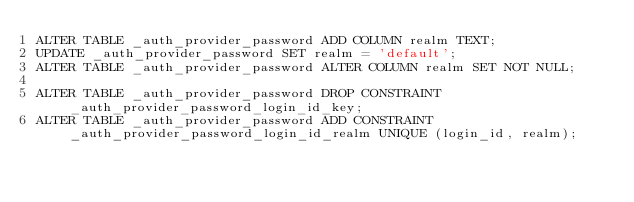Convert code to text. <code><loc_0><loc_0><loc_500><loc_500><_SQL_>ALTER TABLE _auth_provider_password ADD COLUMN realm TEXT;
UPDATE _auth_provider_password SET realm = 'default';
ALTER TABLE _auth_provider_password ALTER COLUMN realm SET NOT NULL;

ALTER TABLE _auth_provider_password DROP CONSTRAINT _auth_provider_password_login_id_key;
ALTER TABLE _auth_provider_password ADD CONSTRAINT  _auth_provider_password_login_id_realm UNIQUE (login_id, realm);
</code> 